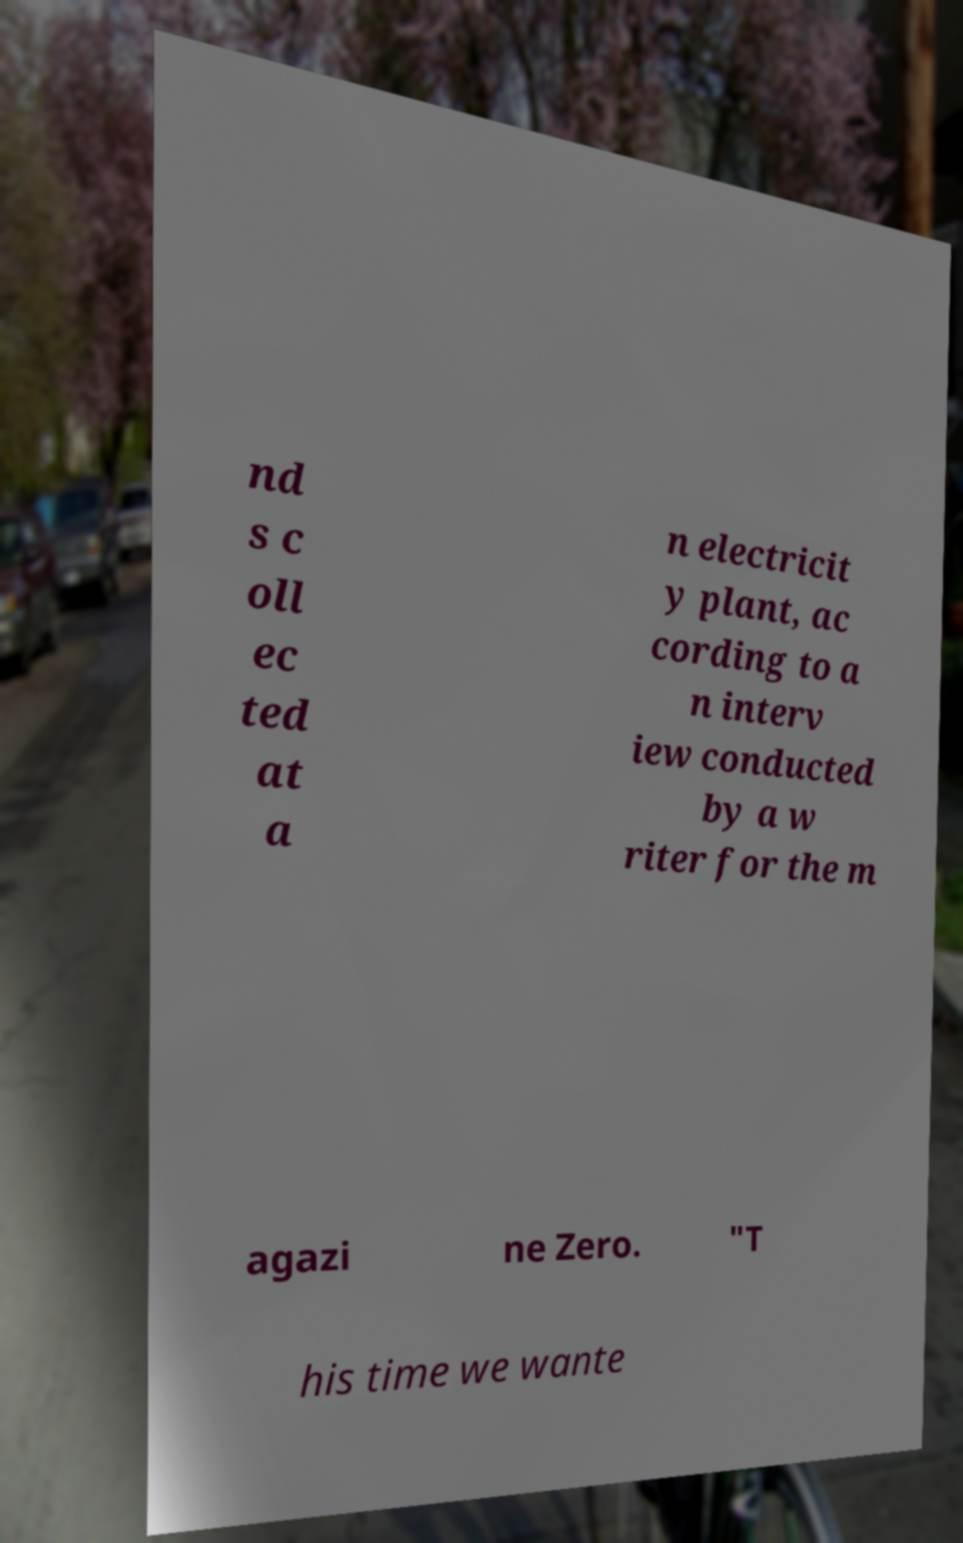Please read and relay the text visible in this image. What does it say? nd s c oll ec ted at a n electricit y plant, ac cording to a n interv iew conducted by a w riter for the m agazi ne Zero. "T his time we wante 